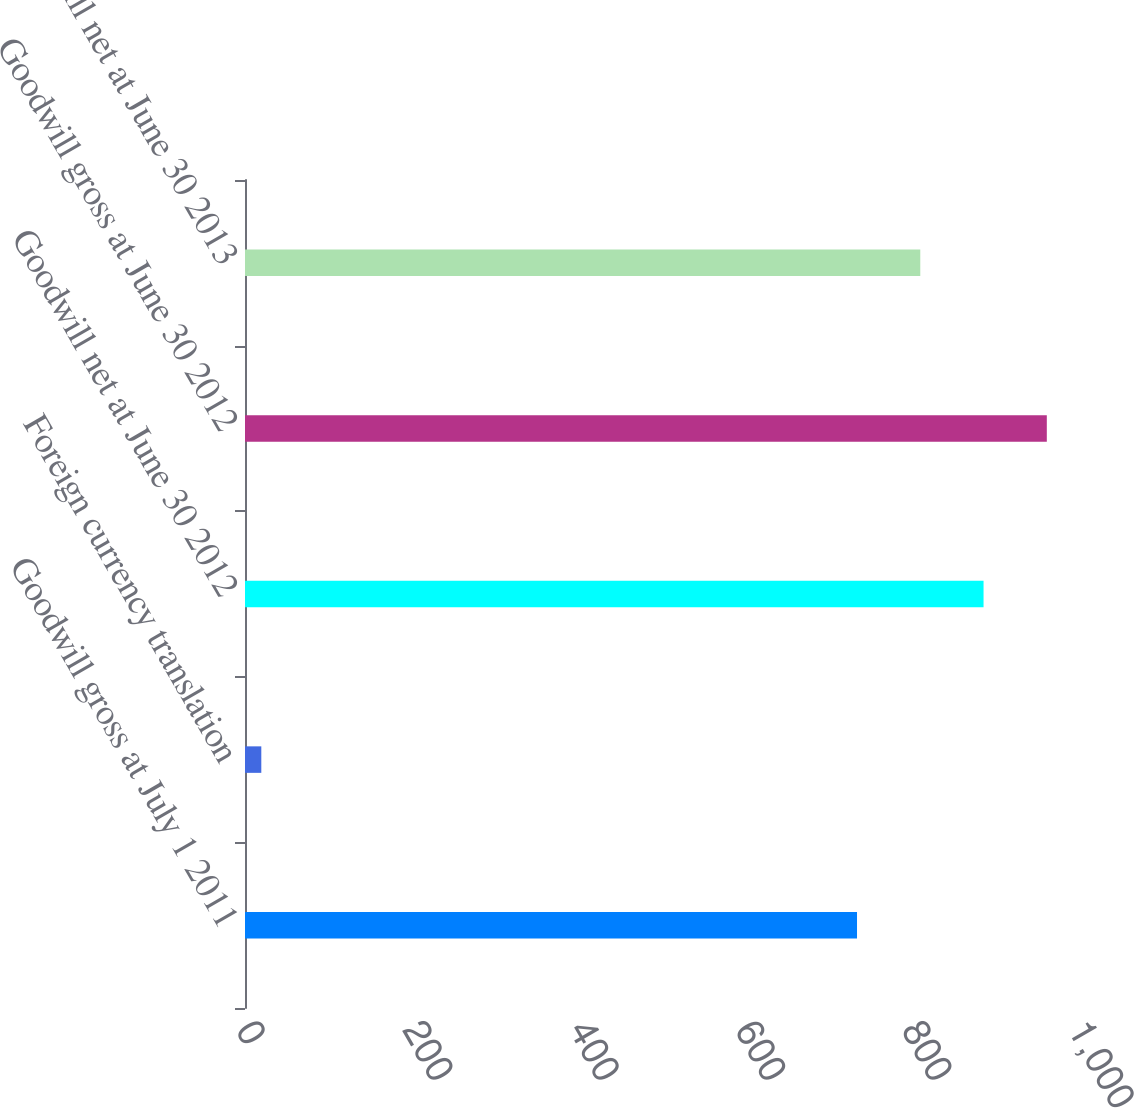Convert chart to OTSL. <chart><loc_0><loc_0><loc_500><loc_500><bar_chart><fcel>Goodwill gross at July 1 2011<fcel>Foreign currency translation<fcel>Goodwill net at June 30 2012<fcel>Goodwill gross at June 30 2012<fcel>Goodwill net at June 30 2013<nl><fcel>735.6<fcel>19.6<fcel>887.68<fcel>963.72<fcel>811.64<nl></chart> 